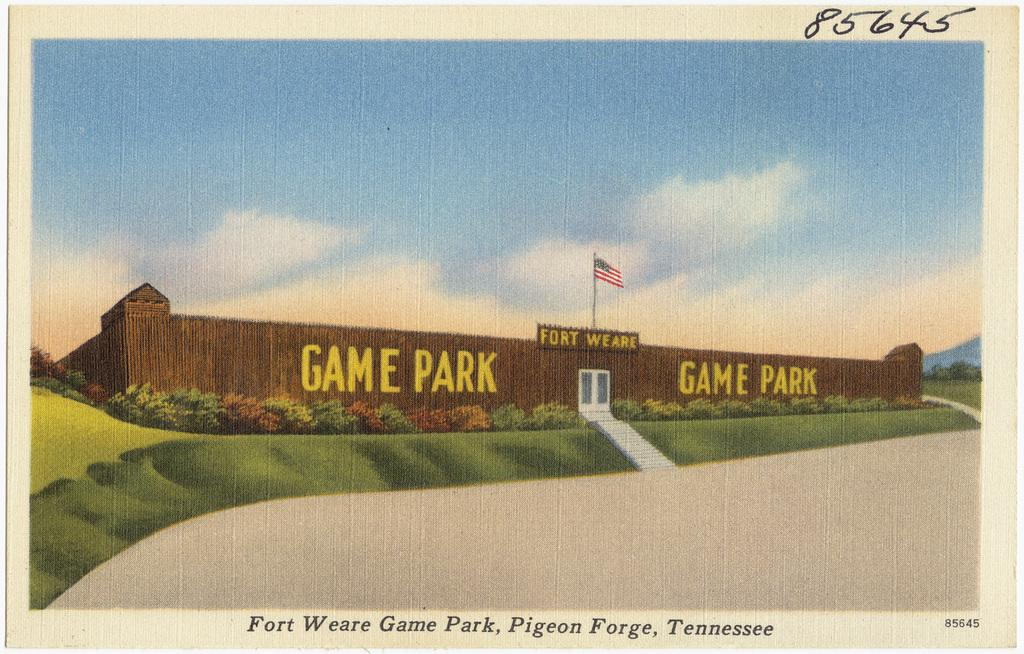<image>
Share a concise interpretation of the image provided. a drawing of game park in fort weare tennessee 